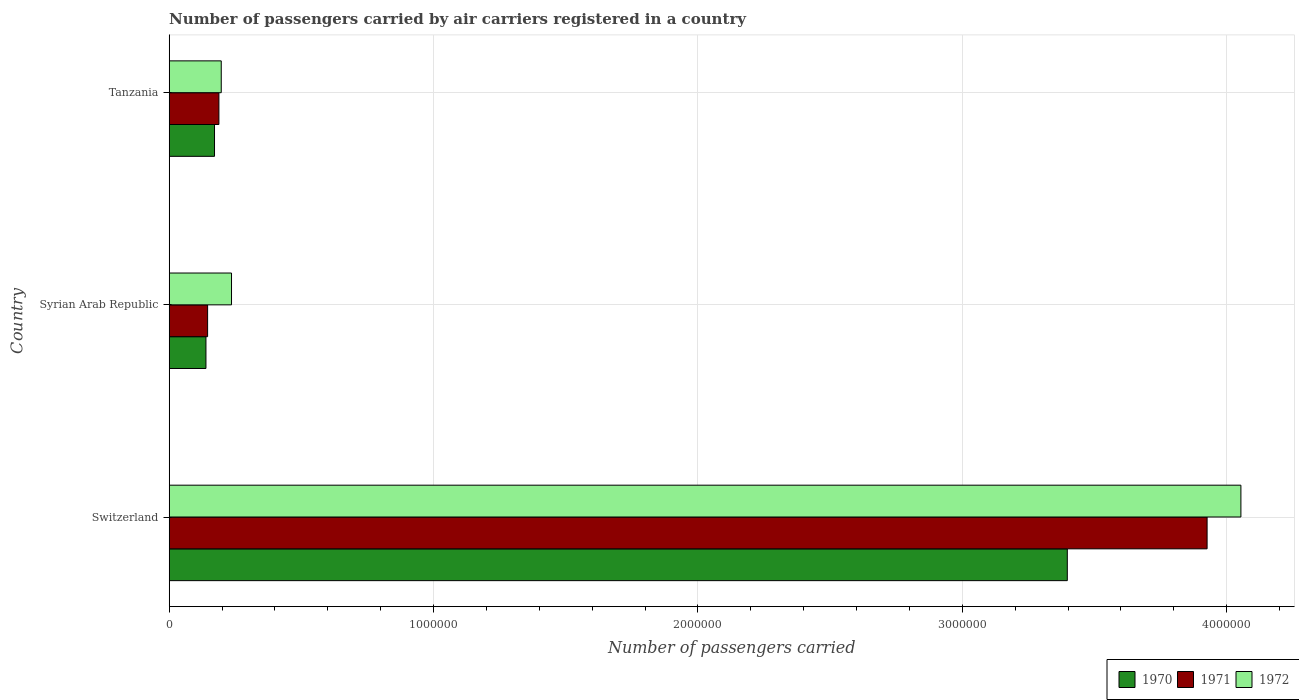What is the label of the 2nd group of bars from the top?
Offer a very short reply. Syrian Arab Republic. In how many cases, is the number of bars for a given country not equal to the number of legend labels?
Your answer should be compact. 0. What is the number of passengers carried by air carriers in 1970 in Tanzania?
Make the answer very short. 1.71e+05. Across all countries, what is the maximum number of passengers carried by air carriers in 1970?
Offer a terse response. 3.40e+06. Across all countries, what is the minimum number of passengers carried by air carriers in 1972?
Your answer should be compact. 1.97e+05. In which country was the number of passengers carried by air carriers in 1972 maximum?
Your answer should be very brief. Switzerland. In which country was the number of passengers carried by air carriers in 1972 minimum?
Make the answer very short. Tanzania. What is the total number of passengers carried by air carriers in 1970 in the graph?
Provide a succinct answer. 3.71e+06. What is the difference between the number of passengers carried by air carriers in 1971 in Switzerland and that in Tanzania?
Make the answer very short. 3.74e+06. What is the difference between the number of passengers carried by air carriers in 1970 in Tanzania and the number of passengers carried by air carriers in 1971 in Switzerland?
Provide a succinct answer. -3.75e+06. What is the average number of passengers carried by air carriers in 1971 per country?
Your answer should be very brief. 1.42e+06. What is the difference between the number of passengers carried by air carriers in 1970 and number of passengers carried by air carriers in 1972 in Tanzania?
Your response must be concise. -2.55e+04. In how many countries, is the number of passengers carried by air carriers in 1971 greater than 2000000 ?
Your answer should be very brief. 1. What is the ratio of the number of passengers carried by air carriers in 1970 in Switzerland to that in Syrian Arab Republic?
Your answer should be compact. 24.44. Is the number of passengers carried by air carriers in 1971 in Switzerland less than that in Tanzania?
Make the answer very short. No. What is the difference between the highest and the second highest number of passengers carried by air carriers in 1970?
Keep it short and to the point. 3.23e+06. What is the difference between the highest and the lowest number of passengers carried by air carriers in 1972?
Make the answer very short. 3.86e+06. In how many countries, is the number of passengers carried by air carriers in 1970 greater than the average number of passengers carried by air carriers in 1970 taken over all countries?
Keep it short and to the point. 1. Is the sum of the number of passengers carried by air carriers in 1970 in Switzerland and Syrian Arab Republic greater than the maximum number of passengers carried by air carriers in 1971 across all countries?
Your answer should be compact. No. What does the 2nd bar from the top in Syrian Arab Republic represents?
Give a very brief answer. 1971. What does the 2nd bar from the bottom in Syrian Arab Republic represents?
Your answer should be very brief. 1971. Is it the case that in every country, the sum of the number of passengers carried by air carriers in 1970 and number of passengers carried by air carriers in 1971 is greater than the number of passengers carried by air carriers in 1972?
Make the answer very short. Yes. How many bars are there?
Your answer should be very brief. 9. Are all the bars in the graph horizontal?
Your response must be concise. Yes. Are the values on the major ticks of X-axis written in scientific E-notation?
Offer a terse response. No. Where does the legend appear in the graph?
Keep it short and to the point. Bottom right. How are the legend labels stacked?
Offer a terse response. Horizontal. What is the title of the graph?
Your answer should be compact. Number of passengers carried by air carriers registered in a country. Does "2012" appear as one of the legend labels in the graph?
Give a very brief answer. No. What is the label or title of the X-axis?
Make the answer very short. Number of passengers carried. What is the Number of passengers carried in 1970 in Switzerland?
Offer a terse response. 3.40e+06. What is the Number of passengers carried in 1971 in Switzerland?
Provide a succinct answer. 3.93e+06. What is the Number of passengers carried in 1972 in Switzerland?
Your answer should be very brief. 4.05e+06. What is the Number of passengers carried in 1970 in Syrian Arab Republic?
Ensure brevity in your answer.  1.39e+05. What is the Number of passengers carried of 1971 in Syrian Arab Republic?
Ensure brevity in your answer.  1.45e+05. What is the Number of passengers carried of 1972 in Syrian Arab Republic?
Your answer should be compact. 2.36e+05. What is the Number of passengers carried of 1970 in Tanzania?
Your answer should be compact. 1.71e+05. What is the Number of passengers carried of 1971 in Tanzania?
Offer a very short reply. 1.88e+05. What is the Number of passengers carried in 1972 in Tanzania?
Give a very brief answer. 1.97e+05. Across all countries, what is the maximum Number of passengers carried in 1970?
Offer a terse response. 3.40e+06. Across all countries, what is the maximum Number of passengers carried in 1971?
Ensure brevity in your answer.  3.93e+06. Across all countries, what is the maximum Number of passengers carried of 1972?
Give a very brief answer. 4.05e+06. Across all countries, what is the minimum Number of passengers carried of 1970?
Your answer should be compact. 1.39e+05. Across all countries, what is the minimum Number of passengers carried in 1971?
Offer a terse response. 1.45e+05. Across all countries, what is the minimum Number of passengers carried of 1972?
Keep it short and to the point. 1.97e+05. What is the total Number of passengers carried in 1970 in the graph?
Provide a short and direct response. 3.71e+06. What is the total Number of passengers carried of 1971 in the graph?
Your response must be concise. 4.26e+06. What is the total Number of passengers carried of 1972 in the graph?
Provide a short and direct response. 4.49e+06. What is the difference between the Number of passengers carried in 1970 in Switzerland and that in Syrian Arab Republic?
Your answer should be compact. 3.26e+06. What is the difference between the Number of passengers carried of 1971 in Switzerland and that in Syrian Arab Republic?
Your answer should be compact. 3.78e+06. What is the difference between the Number of passengers carried of 1972 in Switzerland and that in Syrian Arab Republic?
Your response must be concise. 3.82e+06. What is the difference between the Number of passengers carried in 1970 in Switzerland and that in Tanzania?
Your answer should be very brief. 3.23e+06. What is the difference between the Number of passengers carried of 1971 in Switzerland and that in Tanzania?
Give a very brief answer. 3.74e+06. What is the difference between the Number of passengers carried in 1972 in Switzerland and that in Tanzania?
Provide a short and direct response. 3.86e+06. What is the difference between the Number of passengers carried of 1970 in Syrian Arab Republic and that in Tanzania?
Provide a short and direct response. -3.24e+04. What is the difference between the Number of passengers carried in 1971 in Syrian Arab Republic and that in Tanzania?
Offer a terse response. -4.27e+04. What is the difference between the Number of passengers carried in 1972 in Syrian Arab Republic and that in Tanzania?
Your response must be concise. 3.88e+04. What is the difference between the Number of passengers carried in 1970 in Switzerland and the Number of passengers carried in 1971 in Syrian Arab Republic?
Offer a very short reply. 3.25e+06. What is the difference between the Number of passengers carried in 1970 in Switzerland and the Number of passengers carried in 1972 in Syrian Arab Republic?
Give a very brief answer. 3.16e+06. What is the difference between the Number of passengers carried of 1971 in Switzerland and the Number of passengers carried of 1972 in Syrian Arab Republic?
Your answer should be very brief. 3.69e+06. What is the difference between the Number of passengers carried of 1970 in Switzerland and the Number of passengers carried of 1971 in Tanzania?
Give a very brief answer. 3.21e+06. What is the difference between the Number of passengers carried in 1970 in Switzerland and the Number of passengers carried in 1972 in Tanzania?
Provide a succinct answer. 3.20e+06. What is the difference between the Number of passengers carried in 1971 in Switzerland and the Number of passengers carried in 1972 in Tanzania?
Provide a short and direct response. 3.73e+06. What is the difference between the Number of passengers carried in 1970 in Syrian Arab Republic and the Number of passengers carried in 1971 in Tanzania?
Make the answer very short. -4.90e+04. What is the difference between the Number of passengers carried in 1970 in Syrian Arab Republic and the Number of passengers carried in 1972 in Tanzania?
Give a very brief answer. -5.79e+04. What is the difference between the Number of passengers carried in 1971 in Syrian Arab Republic and the Number of passengers carried in 1972 in Tanzania?
Provide a short and direct response. -5.16e+04. What is the average Number of passengers carried of 1970 per country?
Offer a terse response. 1.24e+06. What is the average Number of passengers carried in 1971 per country?
Your answer should be compact. 1.42e+06. What is the average Number of passengers carried of 1972 per country?
Offer a terse response. 1.50e+06. What is the difference between the Number of passengers carried of 1970 and Number of passengers carried of 1971 in Switzerland?
Ensure brevity in your answer.  -5.29e+05. What is the difference between the Number of passengers carried in 1970 and Number of passengers carried in 1972 in Switzerland?
Your answer should be compact. -6.57e+05. What is the difference between the Number of passengers carried in 1971 and Number of passengers carried in 1972 in Switzerland?
Provide a short and direct response. -1.28e+05. What is the difference between the Number of passengers carried of 1970 and Number of passengers carried of 1971 in Syrian Arab Republic?
Your answer should be very brief. -6300. What is the difference between the Number of passengers carried in 1970 and Number of passengers carried in 1972 in Syrian Arab Republic?
Offer a very short reply. -9.67e+04. What is the difference between the Number of passengers carried in 1971 and Number of passengers carried in 1972 in Syrian Arab Republic?
Offer a very short reply. -9.04e+04. What is the difference between the Number of passengers carried of 1970 and Number of passengers carried of 1971 in Tanzania?
Your answer should be compact. -1.66e+04. What is the difference between the Number of passengers carried of 1970 and Number of passengers carried of 1972 in Tanzania?
Make the answer very short. -2.55e+04. What is the difference between the Number of passengers carried in 1971 and Number of passengers carried in 1972 in Tanzania?
Your answer should be compact. -8900. What is the ratio of the Number of passengers carried of 1970 in Switzerland to that in Syrian Arab Republic?
Offer a very short reply. 24.44. What is the ratio of the Number of passengers carried in 1971 in Switzerland to that in Syrian Arab Republic?
Your response must be concise. 27.02. What is the ratio of the Number of passengers carried of 1972 in Switzerland to that in Syrian Arab Republic?
Make the answer very short. 17.2. What is the ratio of the Number of passengers carried in 1970 in Switzerland to that in Tanzania?
Your answer should be very brief. 19.82. What is the ratio of the Number of passengers carried in 1971 in Switzerland to that in Tanzania?
Your answer should be compact. 20.88. What is the ratio of the Number of passengers carried of 1972 in Switzerland to that in Tanzania?
Keep it short and to the point. 20.59. What is the ratio of the Number of passengers carried in 1970 in Syrian Arab Republic to that in Tanzania?
Provide a short and direct response. 0.81. What is the ratio of the Number of passengers carried of 1971 in Syrian Arab Republic to that in Tanzania?
Make the answer very short. 0.77. What is the ratio of the Number of passengers carried in 1972 in Syrian Arab Republic to that in Tanzania?
Your response must be concise. 1.2. What is the difference between the highest and the second highest Number of passengers carried of 1970?
Make the answer very short. 3.23e+06. What is the difference between the highest and the second highest Number of passengers carried in 1971?
Give a very brief answer. 3.74e+06. What is the difference between the highest and the second highest Number of passengers carried of 1972?
Offer a terse response. 3.82e+06. What is the difference between the highest and the lowest Number of passengers carried of 1970?
Your response must be concise. 3.26e+06. What is the difference between the highest and the lowest Number of passengers carried in 1971?
Ensure brevity in your answer.  3.78e+06. What is the difference between the highest and the lowest Number of passengers carried in 1972?
Keep it short and to the point. 3.86e+06. 